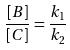<formula> <loc_0><loc_0><loc_500><loc_500>\frac { [ B ] } { [ C ] } = \frac { k _ { 1 } } { k _ { 2 } }</formula> 